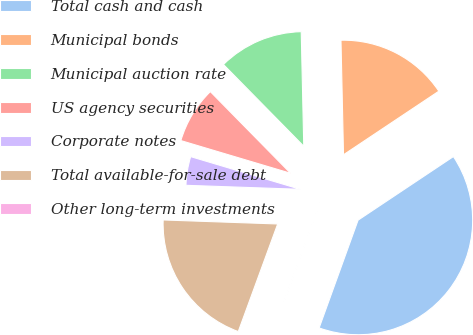Convert chart to OTSL. <chart><loc_0><loc_0><loc_500><loc_500><pie_chart><fcel>Total cash and cash<fcel>Municipal bonds<fcel>Municipal auction rate<fcel>US agency securities<fcel>Corporate notes<fcel>Total available-for-sale debt<fcel>Other long-term investments<nl><fcel>39.88%<fcel>15.99%<fcel>12.01%<fcel>8.03%<fcel>4.05%<fcel>19.97%<fcel>0.07%<nl></chart> 